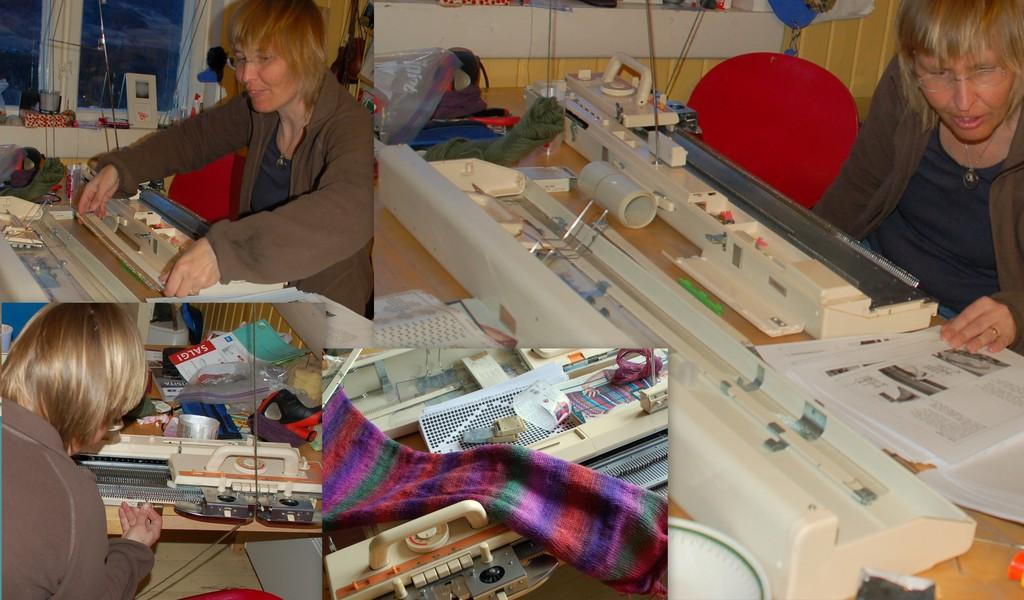What type of items can be seen in the image? There are papers and cloth in the image. What architectural feature is present in the image? There are windows in the image. What type of furniture is in the image? There is a chair in the image. Can you describe the other objects in the image? There are some other objects in the image, but their specific details are not mentioned in the provided facts. How many chickens are sitting on the oranges in the image? There are no chickens or oranges present in the image. 